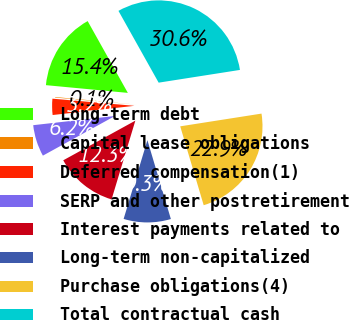Convert chart. <chart><loc_0><loc_0><loc_500><loc_500><pie_chart><fcel>Long-term debt<fcel>Capital lease obligations<fcel>Deferred compensation(1)<fcel>SERP and other postretirement<fcel>Interest payments related to<fcel>Long-term non-capitalized<fcel>Purchase obligations(4)<fcel>Total contractual cash<nl><fcel>15.38%<fcel>0.11%<fcel>3.17%<fcel>6.22%<fcel>12.33%<fcel>9.27%<fcel>22.87%<fcel>30.65%<nl></chart> 